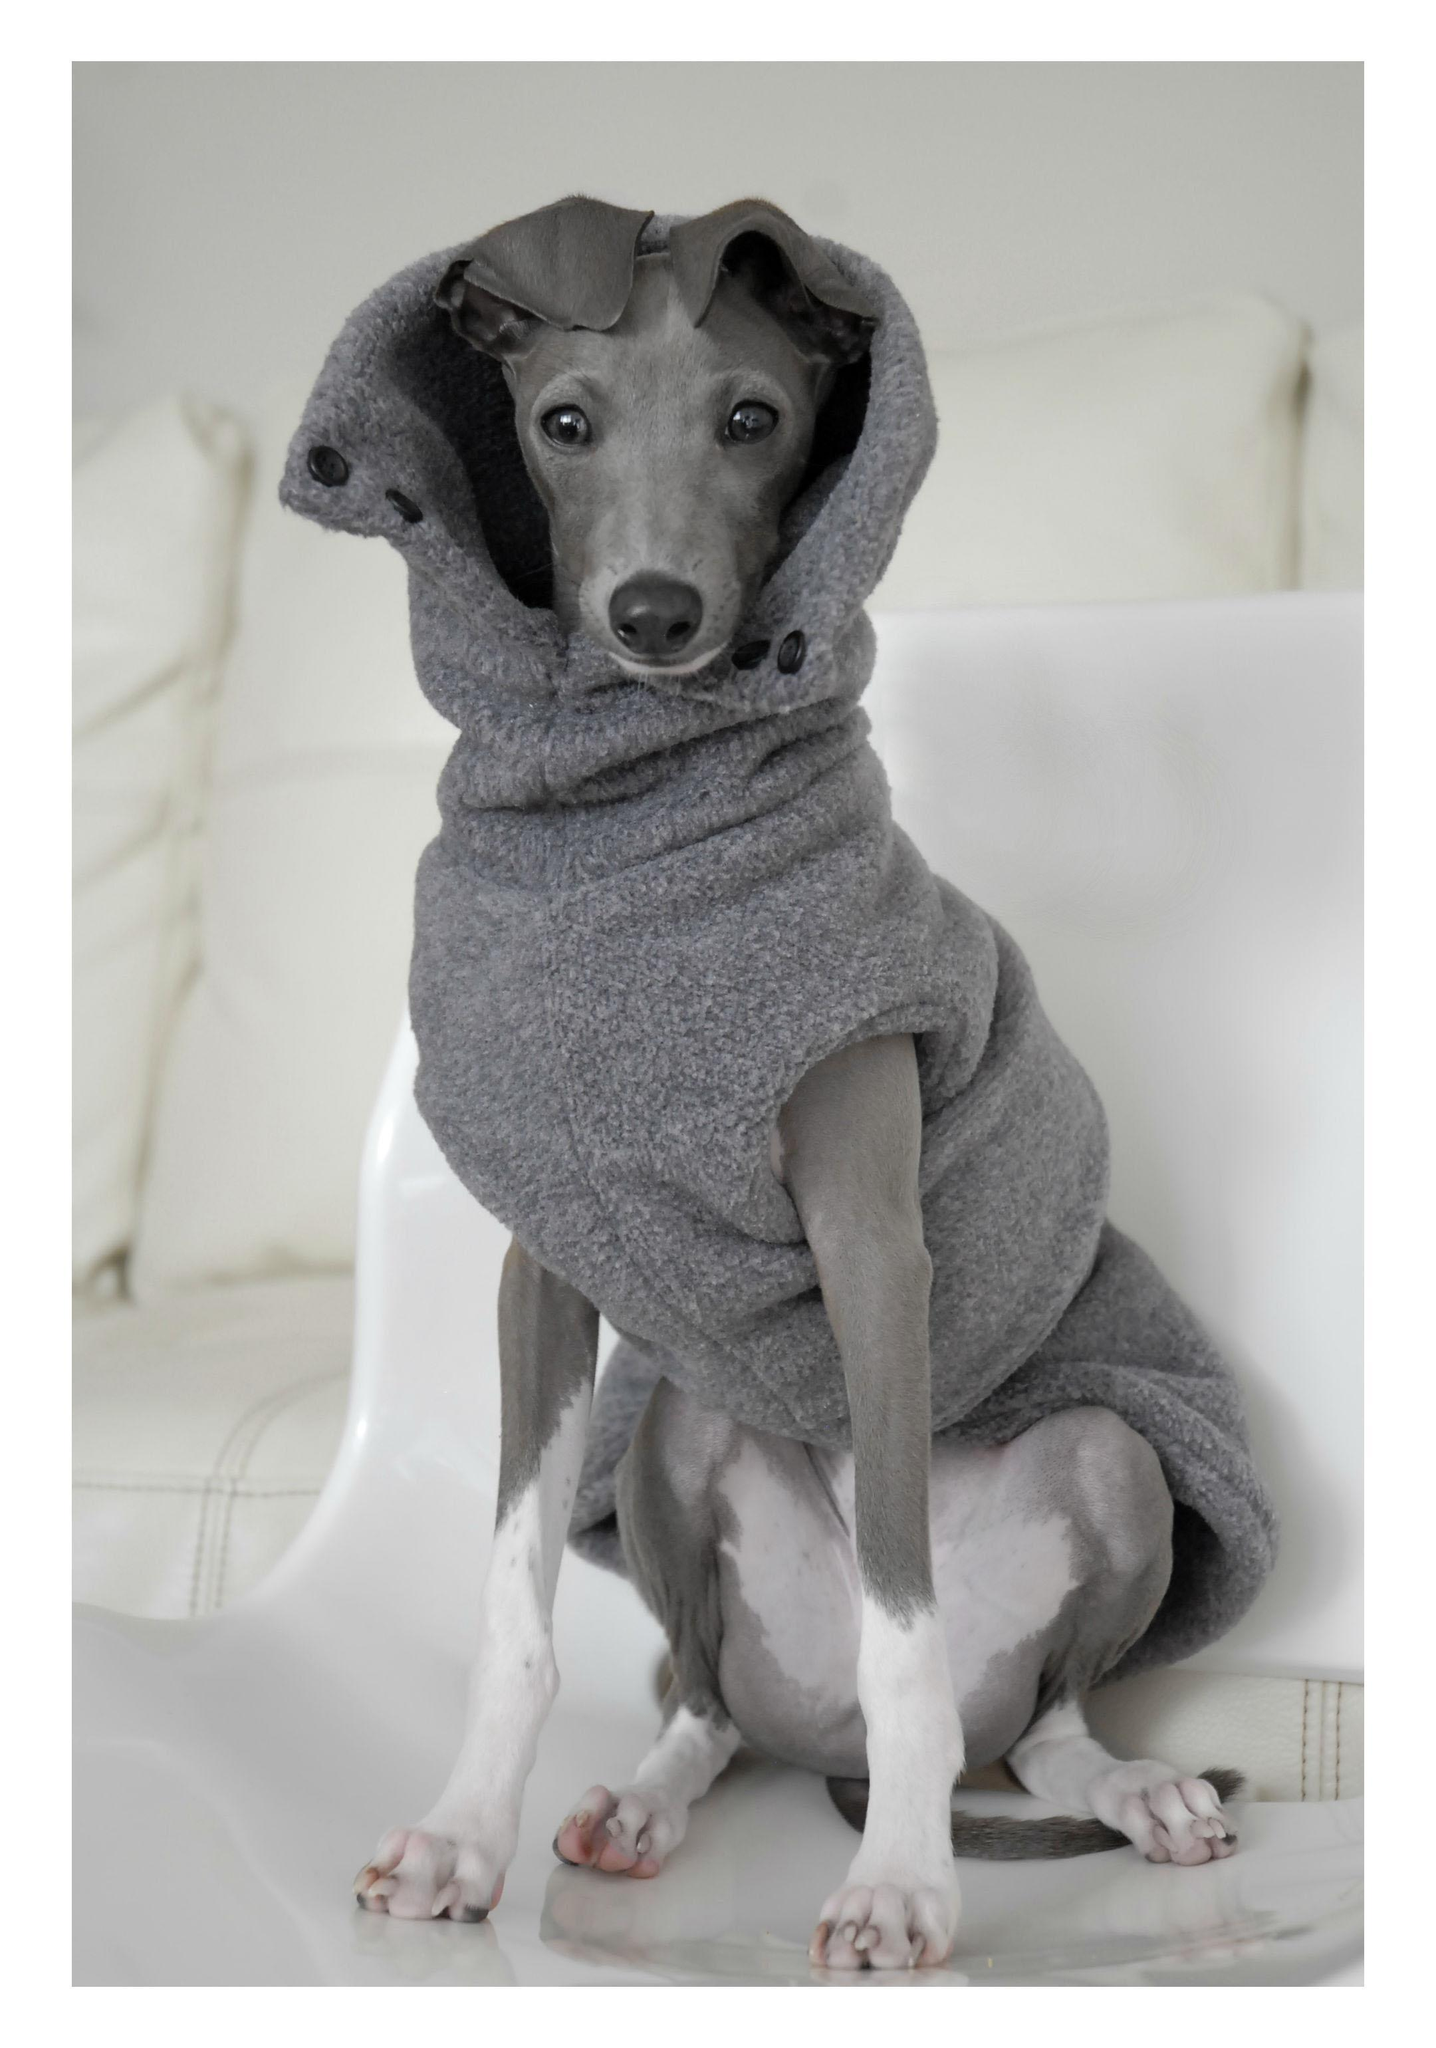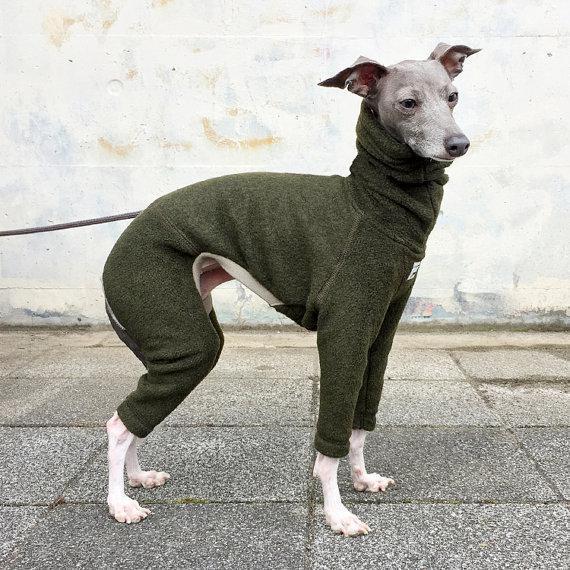The first image is the image on the left, the second image is the image on the right. For the images shown, is this caption "At least one dog is sitting." true? Answer yes or no. Yes. The first image is the image on the left, the second image is the image on the right. For the images displayed, is the sentence "In the left image, there's an Italian Greyhound wearing a sweater and sitting." factually correct? Answer yes or no. Yes. 